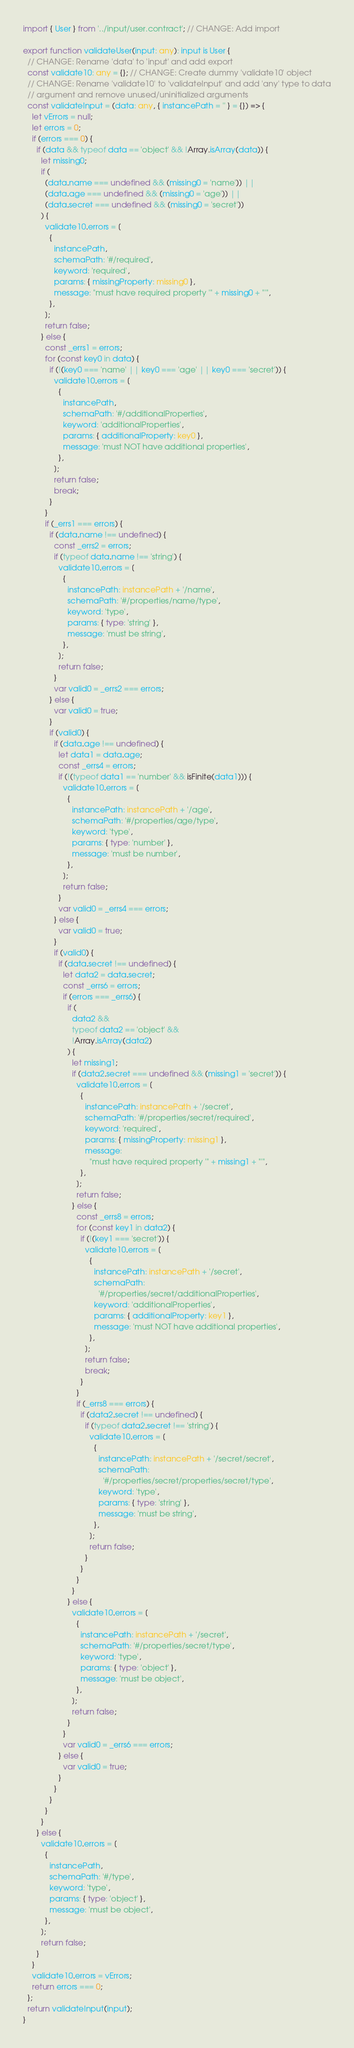<code> <loc_0><loc_0><loc_500><loc_500><_TypeScript_>import { User } from '../input/user.contract'; // CHANGE: Add import

export function validateUser(input: any): input is User {
  // CHANGE: Rename 'data' to 'input' and add export
  const validate10: any = {}; // CHANGE: Create dummy 'validate10' object
  // CHANGE: Rename 'validate10' to 'validateInput' and add 'any' type to data
  // argument and remove unused/uninitialized arguments
  const validateInput = (data: any, { instancePath = '' } = {}) => {
    let vErrors = null;
    let errors = 0;
    if (errors === 0) {
      if (data && typeof data == 'object' && !Array.isArray(data)) {
        let missing0;
        if (
          (data.name === undefined && (missing0 = 'name')) ||
          (data.age === undefined && (missing0 = 'age')) ||
          (data.secret === undefined && (missing0 = 'secret'))
        ) {
          validate10.errors = [
            {
              instancePath,
              schemaPath: '#/required',
              keyword: 'required',
              params: { missingProperty: missing0 },
              message: "must have required property '" + missing0 + "'",
            },
          ];
          return false;
        } else {
          const _errs1 = errors;
          for (const key0 in data) {
            if (!(key0 === 'name' || key0 === 'age' || key0 === 'secret')) {
              validate10.errors = [
                {
                  instancePath,
                  schemaPath: '#/additionalProperties',
                  keyword: 'additionalProperties',
                  params: { additionalProperty: key0 },
                  message: 'must NOT have additional properties',
                },
              ];
              return false;
              break;
            }
          }
          if (_errs1 === errors) {
            if (data.name !== undefined) {
              const _errs2 = errors;
              if (typeof data.name !== 'string') {
                validate10.errors = [
                  {
                    instancePath: instancePath + '/name',
                    schemaPath: '#/properties/name/type',
                    keyword: 'type',
                    params: { type: 'string' },
                    message: 'must be string',
                  },
                ];
                return false;
              }
              var valid0 = _errs2 === errors;
            } else {
              var valid0 = true;
            }
            if (valid0) {
              if (data.age !== undefined) {
                let data1 = data.age;
                const _errs4 = errors;
                if (!(typeof data1 == 'number' && isFinite(data1))) {
                  validate10.errors = [
                    {
                      instancePath: instancePath + '/age',
                      schemaPath: '#/properties/age/type',
                      keyword: 'type',
                      params: { type: 'number' },
                      message: 'must be number',
                    },
                  ];
                  return false;
                }
                var valid0 = _errs4 === errors;
              } else {
                var valid0 = true;
              }
              if (valid0) {
                if (data.secret !== undefined) {
                  let data2 = data.secret;
                  const _errs6 = errors;
                  if (errors === _errs6) {
                    if (
                      data2 &&
                      typeof data2 == 'object' &&
                      !Array.isArray(data2)
                    ) {
                      let missing1;
                      if (data2.secret === undefined && (missing1 = 'secret')) {
                        validate10.errors = [
                          {
                            instancePath: instancePath + '/secret',
                            schemaPath: '#/properties/secret/required',
                            keyword: 'required',
                            params: { missingProperty: missing1 },
                            message:
                              "must have required property '" + missing1 + "'",
                          },
                        ];
                        return false;
                      } else {
                        const _errs8 = errors;
                        for (const key1 in data2) {
                          if (!(key1 === 'secret')) {
                            validate10.errors = [
                              {
                                instancePath: instancePath + '/secret',
                                schemaPath:
                                  '#/properties/secret/additionalProperties',
                                keyword: 'additionalProperties',
                                params: { additionalProperty: key1 },
                                message: 'must NOT have additional properties',
                              },
                            ];
                            return false;
                            break;
                          }
                        }
                        if (_errs8 === errors) {
                          if (data2.secret !== undefined) {
                            if (typeof data2.secret !== 'string') {
                              validate10.errors = [
                                {
                                  instancePath: instancePath + '/secret/secret',
                                  schemaPath:
                                    '#/properties/secret/properties/secret/type',
                                  keyword: 'type',
                                  params: { type: 'string' },
                                  message: 'must be string',
                                },
                              ];
                              return false;
                            }
                          }
                        }
                      }
                    } else {
                      validate10.errors = [
                        {
                          instancePath: instancePath + '/secret',
                          schemaPath: '#/properties/secret/type',
                          keyword: 'type',
                          params: { type: 'object' },
                          message: 'must be object',
                        },
                      ];
                      return false;
                    }
                  }
                  var valid0 = _errs6 === errors;
                } else {
                  var valid0 = true;
                }
              }
            }
          }
        }
      } else {
        validate10.errors = [
          {
            instancePath,
            schemaPath: '#/type',
            keyword: 'type',
            params: { type: 'object' },
            message: 'must be object',
          },
        ];
        return false;
      }
    }
    validate10.errors = vErrors;
    return errors === 0;
  };
  return validateInput(input);
}
</code> 